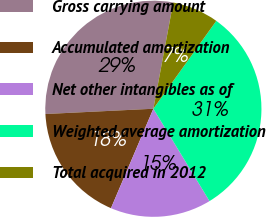Convert chart. <chart><loc_0><loc_0><loc_500><loc_500><pie_chart><fcel>Gross carrying amount<fcel>Accumulated amortization<fcel>Net other intangibles as of<fcel>Weighted average amortization<fcel>Total acquired in 2012<nl><fcel>28.72%<fcel>17.81%<fcel>15.11%<fcel>31.41%<fcel>6.95%<nl></chart> 